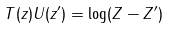Convert formula to latex. <formula><loc_0><loc_0><loc_500><loc_500>T ( z ) U ( z ^ { \prime } ) = \log ( Z - Z ^ { \prime } )</formula> 